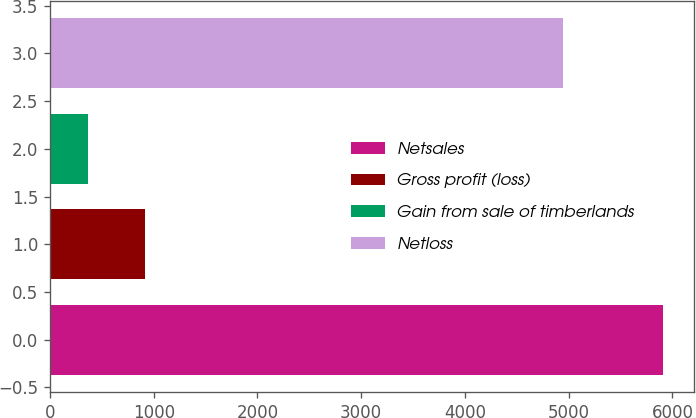Convert chart. <chart><loc_0><loc_0><loc_500><loc_500><bar_chart><fcel>Netsales<fcel>Gross profit (loss)<fcel>Gain from sale of timberlands<fcel>Netloss<nl><fcel>5910<fcel>918.6<fcel>364<fcel>4947<nl></chart> 